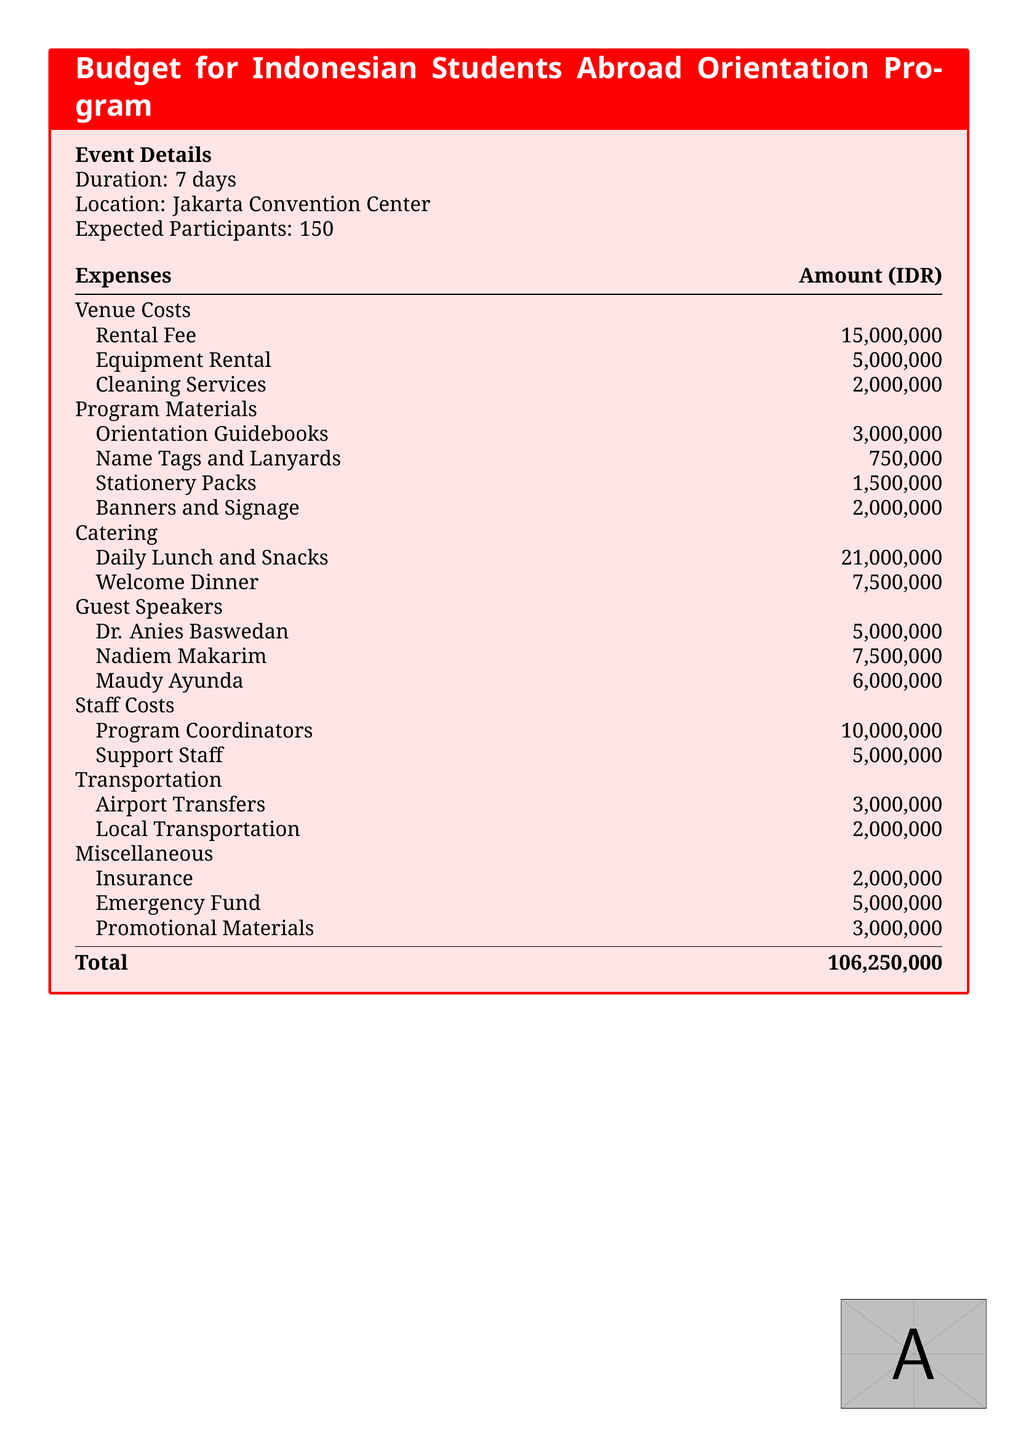what is the duration of the orientation program? The duration is mentioned in the event details section of the document.
Answer: 7 days where is the location of the program? The document specifies the venue location under the event details section.
Answer: Jakarta Convention Center how many expected participants are there? The expected number of participants is listed in the event details section of the document.
Answer: 150 what is the amount allocated for catering? The catering costs are grouped together in the expenses section, and their total is presented.
Answer: 28,500,000 who is one of the guest speakers? The document lists the guest speakers under the guest speakers expenses.
Answer: Dr. Anies Baswedan what is the total budget for the orientation program? The total amount is summarized at the end of the expenses section.
Answer: 106,250,000 how much does the rental fee for the venue cost? The venue costs include specific fees, one of which is the rental fee mentioned in the document.
Answer: 15,000,000 what is the cost for daily lunch and snacks? This expense is categorized under catering in the expenses section of the document.
Answer: 21,000,000 how much is the emergency fund set aside? The emergency fund is listed in the miscellaneous section of the budget.
Answer: 5,000,000 